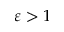<formula> <loc_0><loc_0><loc_500><loc_500>\varepsilon > 1</formula> 